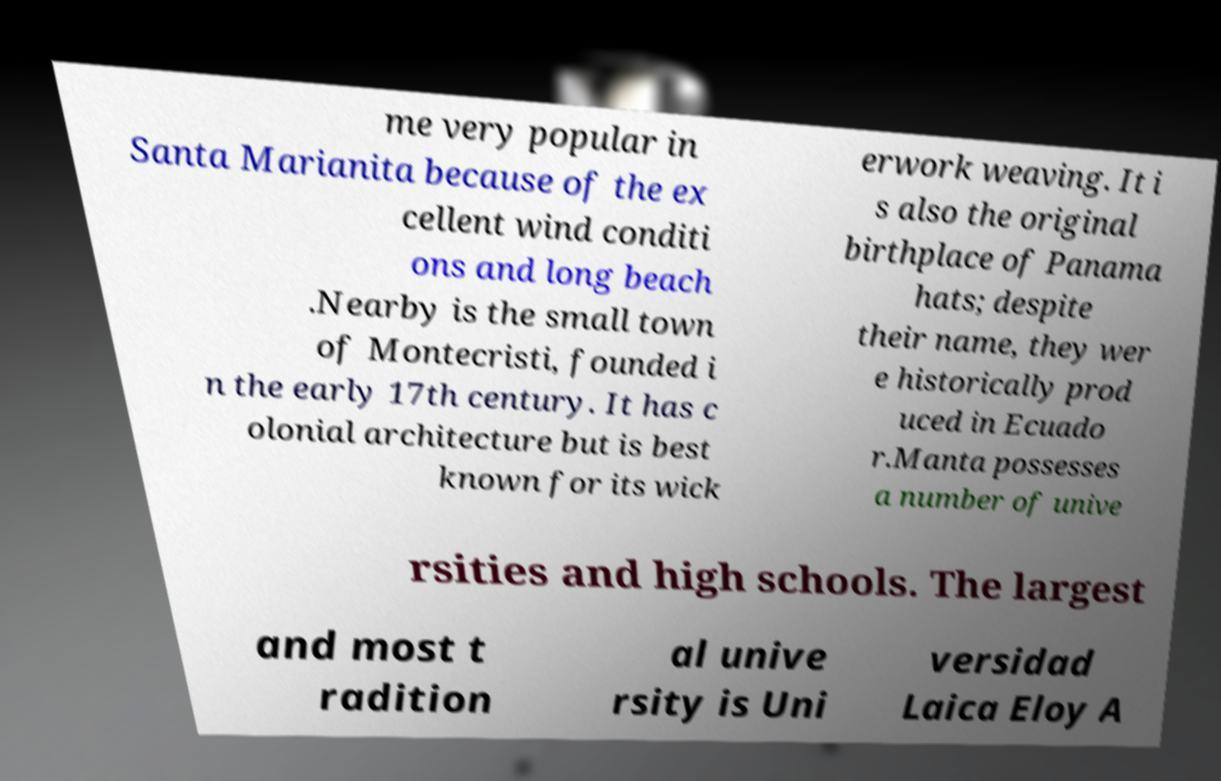What messages or text are displayed in this image? I need them in a readable, typed format. me very popular in Santa Marianita because of the ex cellent wind conditi ons and long beach .Nearby is the small town of Montecristi, founded i n the early 17th century. It has c olonial architecture but is best known for its wick erwork weaving. It i s also the original birthplace of Panama hats; despite their name, they wer e historically prod uced in Ecuado r.Manta possesses a number of unive rsities and high schools. The largest and most t radition al unive rsity is Uni versidad Laica Eloy A 